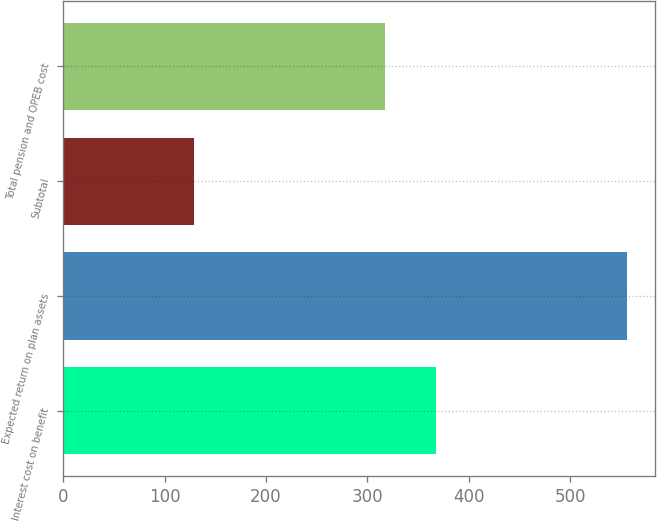<chart> <loc_0><loc_0><loc_500><loc_500><bar_chart><fcel>Interest cost on benefit<fcel>Expected return on plan assets<fcel>Subtotal<fcel>Total pension and OPEB cost<nl><fcel>368<fcel>556<fcel>129<fcel>317<nl></chart> 